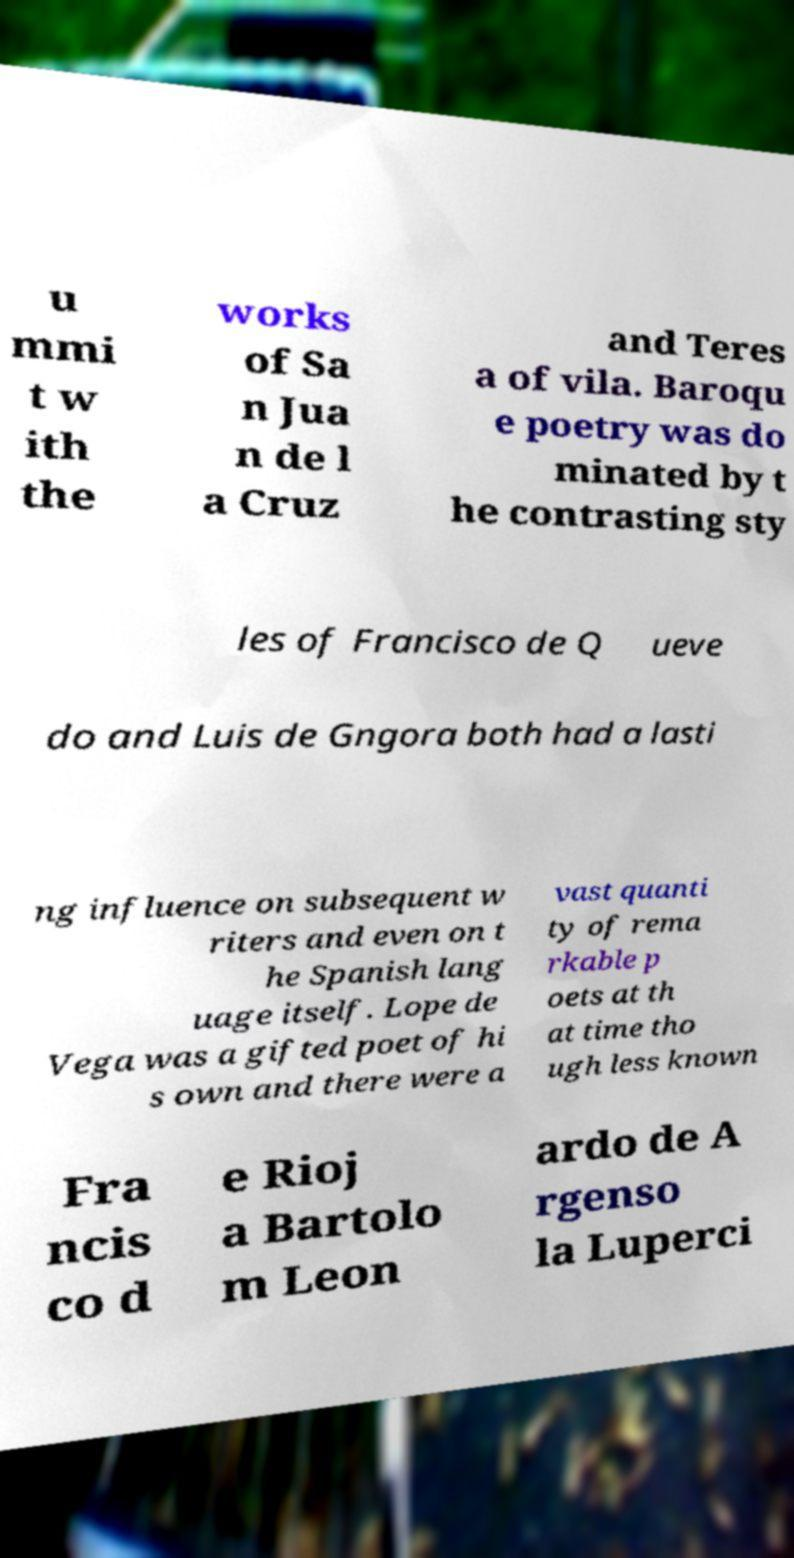I need the written content from this picture converted into text. Can you do that? u mmi t w ith the works of Sa n Jua n de l a Cruz and Teres a of vila. Baroqu e poetry was do minated by t he contrasting sty les of Francisco de Q ueve do and Luis de Gngora both had a lasti ng influence on subsequent w riters and even on t he Spanish lang uage itself. Lope de Vega was a gifted poet of hi s own and there were a vast quanti ty of rema rkable p oets at th at time tho ugh less known Fra ncis co d e Rioj a Bartolo m Leon ardo de A rgenso la Luperci 